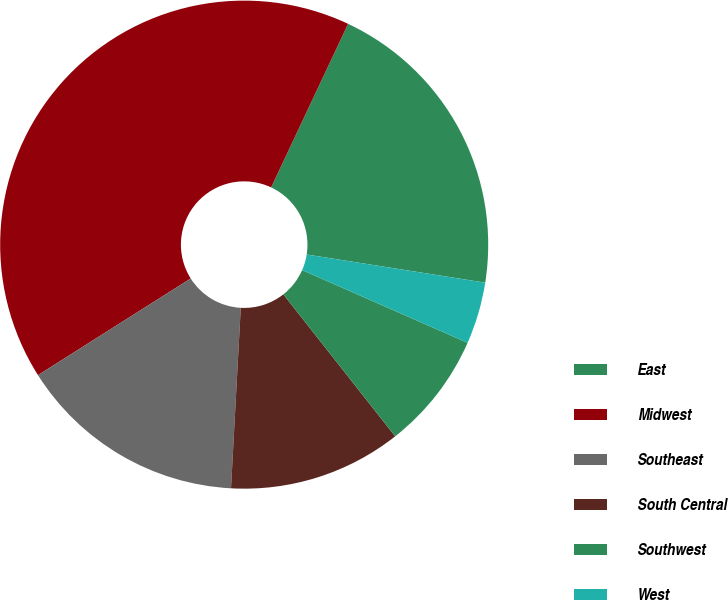<chart> <loc_0><loc_0><loc_500><loc_500><pie_chart><fcel>East<fcel>Midwest<fcel>Southeast<fcel>South Central<fcel>Southwest<fcel>West<nl><fcel>20.49%<fcel>40.98%<fcel>15.16%<fcel>11.48%<fcel>7.79%<fcel>4.1%<nl></chart> 